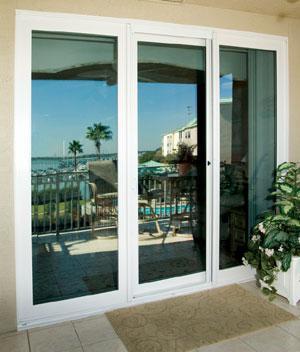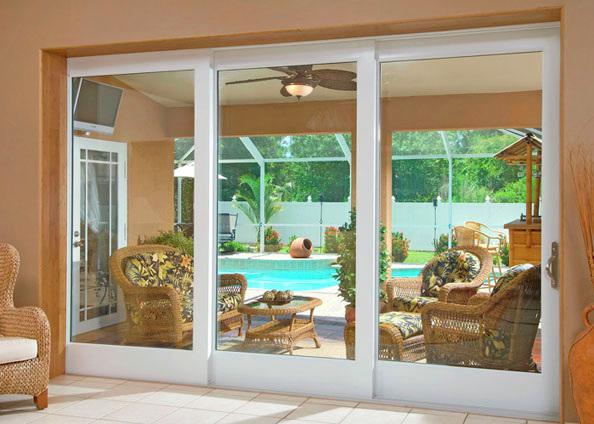The first image is the image on the left, the second image is the image on the right. Assess this claim about the two images: "Three equal size segments make up each glass door and window panel installation with discreet door hardware visible on one panel.". Correct or not? Answer yes or no. Yes. 